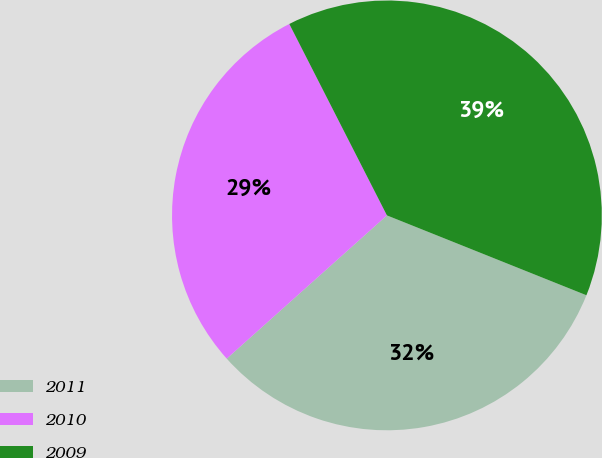Convert chart. <chart><loc_0><loc_0><loc_500><loc_500><pie_chart><fcel>2011<fcel>2010<fcel>2009<nl><fcel>32.33%<fcel>29.11%<fcel>38.57%<nl></chart> 